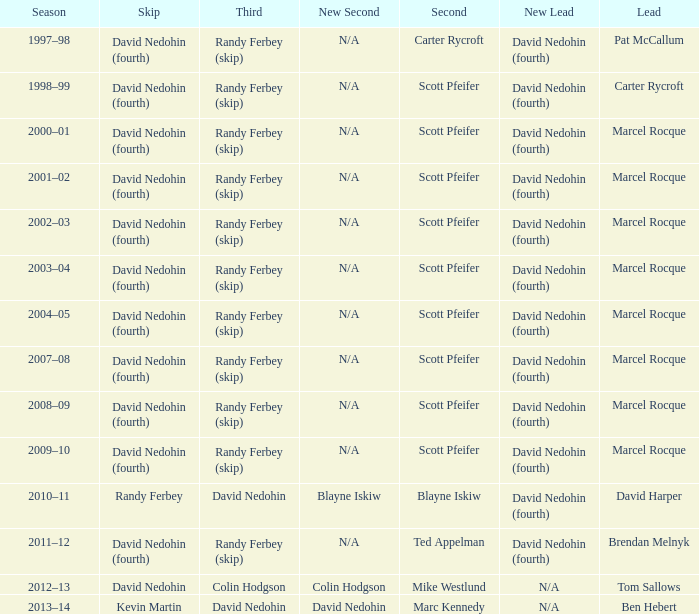Which Second has a Third of david nedohin, and a Lead of ben hebert? Marc Kennedy. 